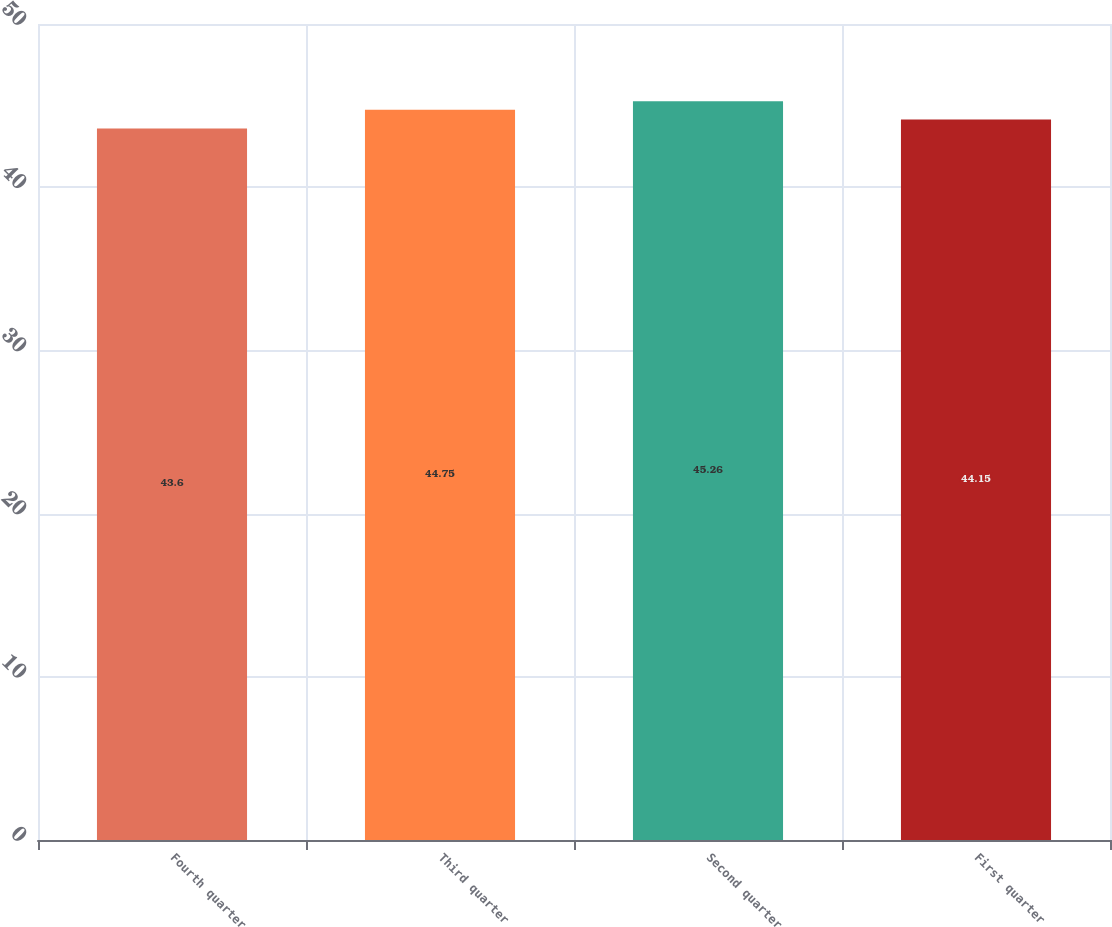Convert chart to OTSL. <chart><loc_0><loc_0><loc_500><loc_500><bar_chart><fcel>Fourth quarter<fcel>Third quarter<fcel>Second quarter<fcel>First quarter<nl><fcel>43.6<fcel>44.75<fcel>45.26<fcel>44.15<nl></chart> 